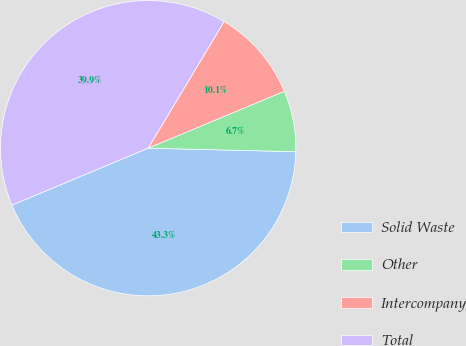Convert chart to OTSL. <chart><loc_0><loc_0><loc_500><loc_500><pie_chart><fcel>Solid Waste<fcel>Other<fcel>Intercompany<fcel>Total<nl><fcel>43.32%<fcel>6.68%<fcel>10.1%<fcel>39.9%<nl></chart> 